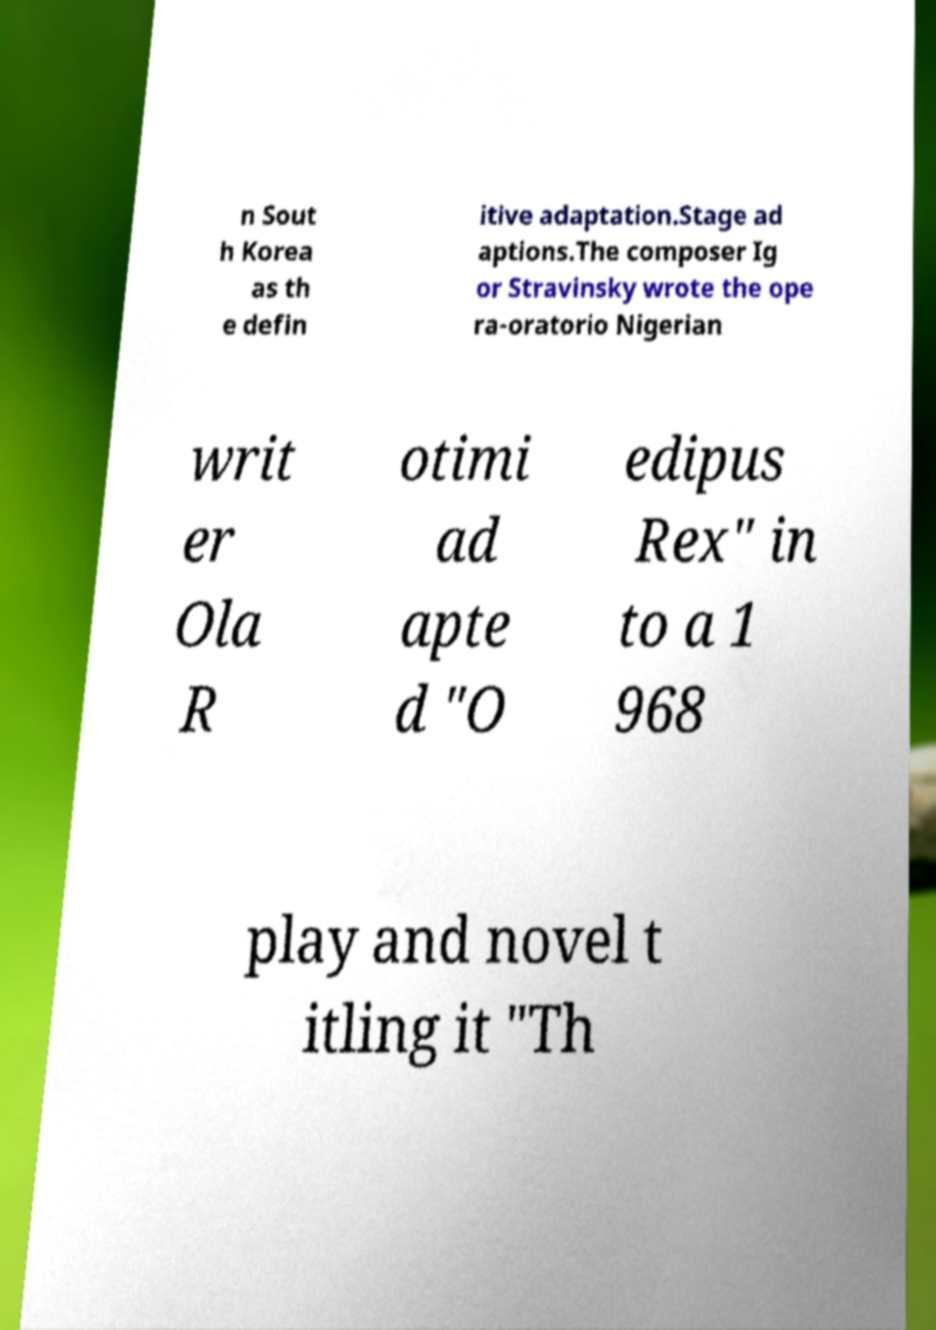For documentation purposes, I need the text within this image transcribed. Could you provide that? n Sout h Korea as th e defin itive adaptation.Stage ad aptions.The composer Ig or Stravinsky wrote the ope ra-oratorio Nigerian writ er Ola R otimi ad apte d "O edipus Rex" in to a 1 968 play and novel t itling it "Th 